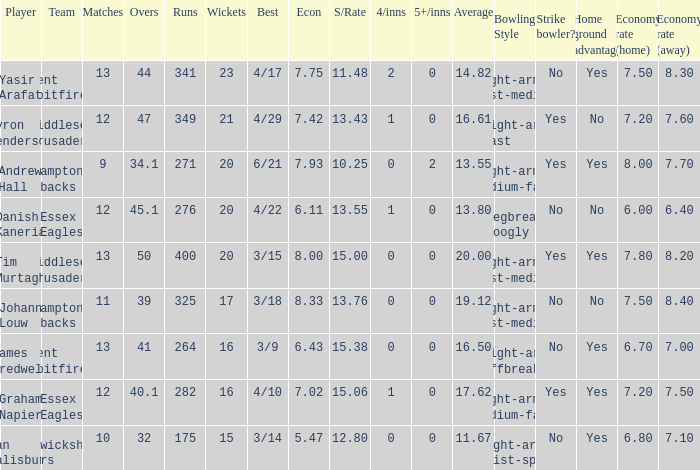Name the most wickets for best is 4/22 20.0. 